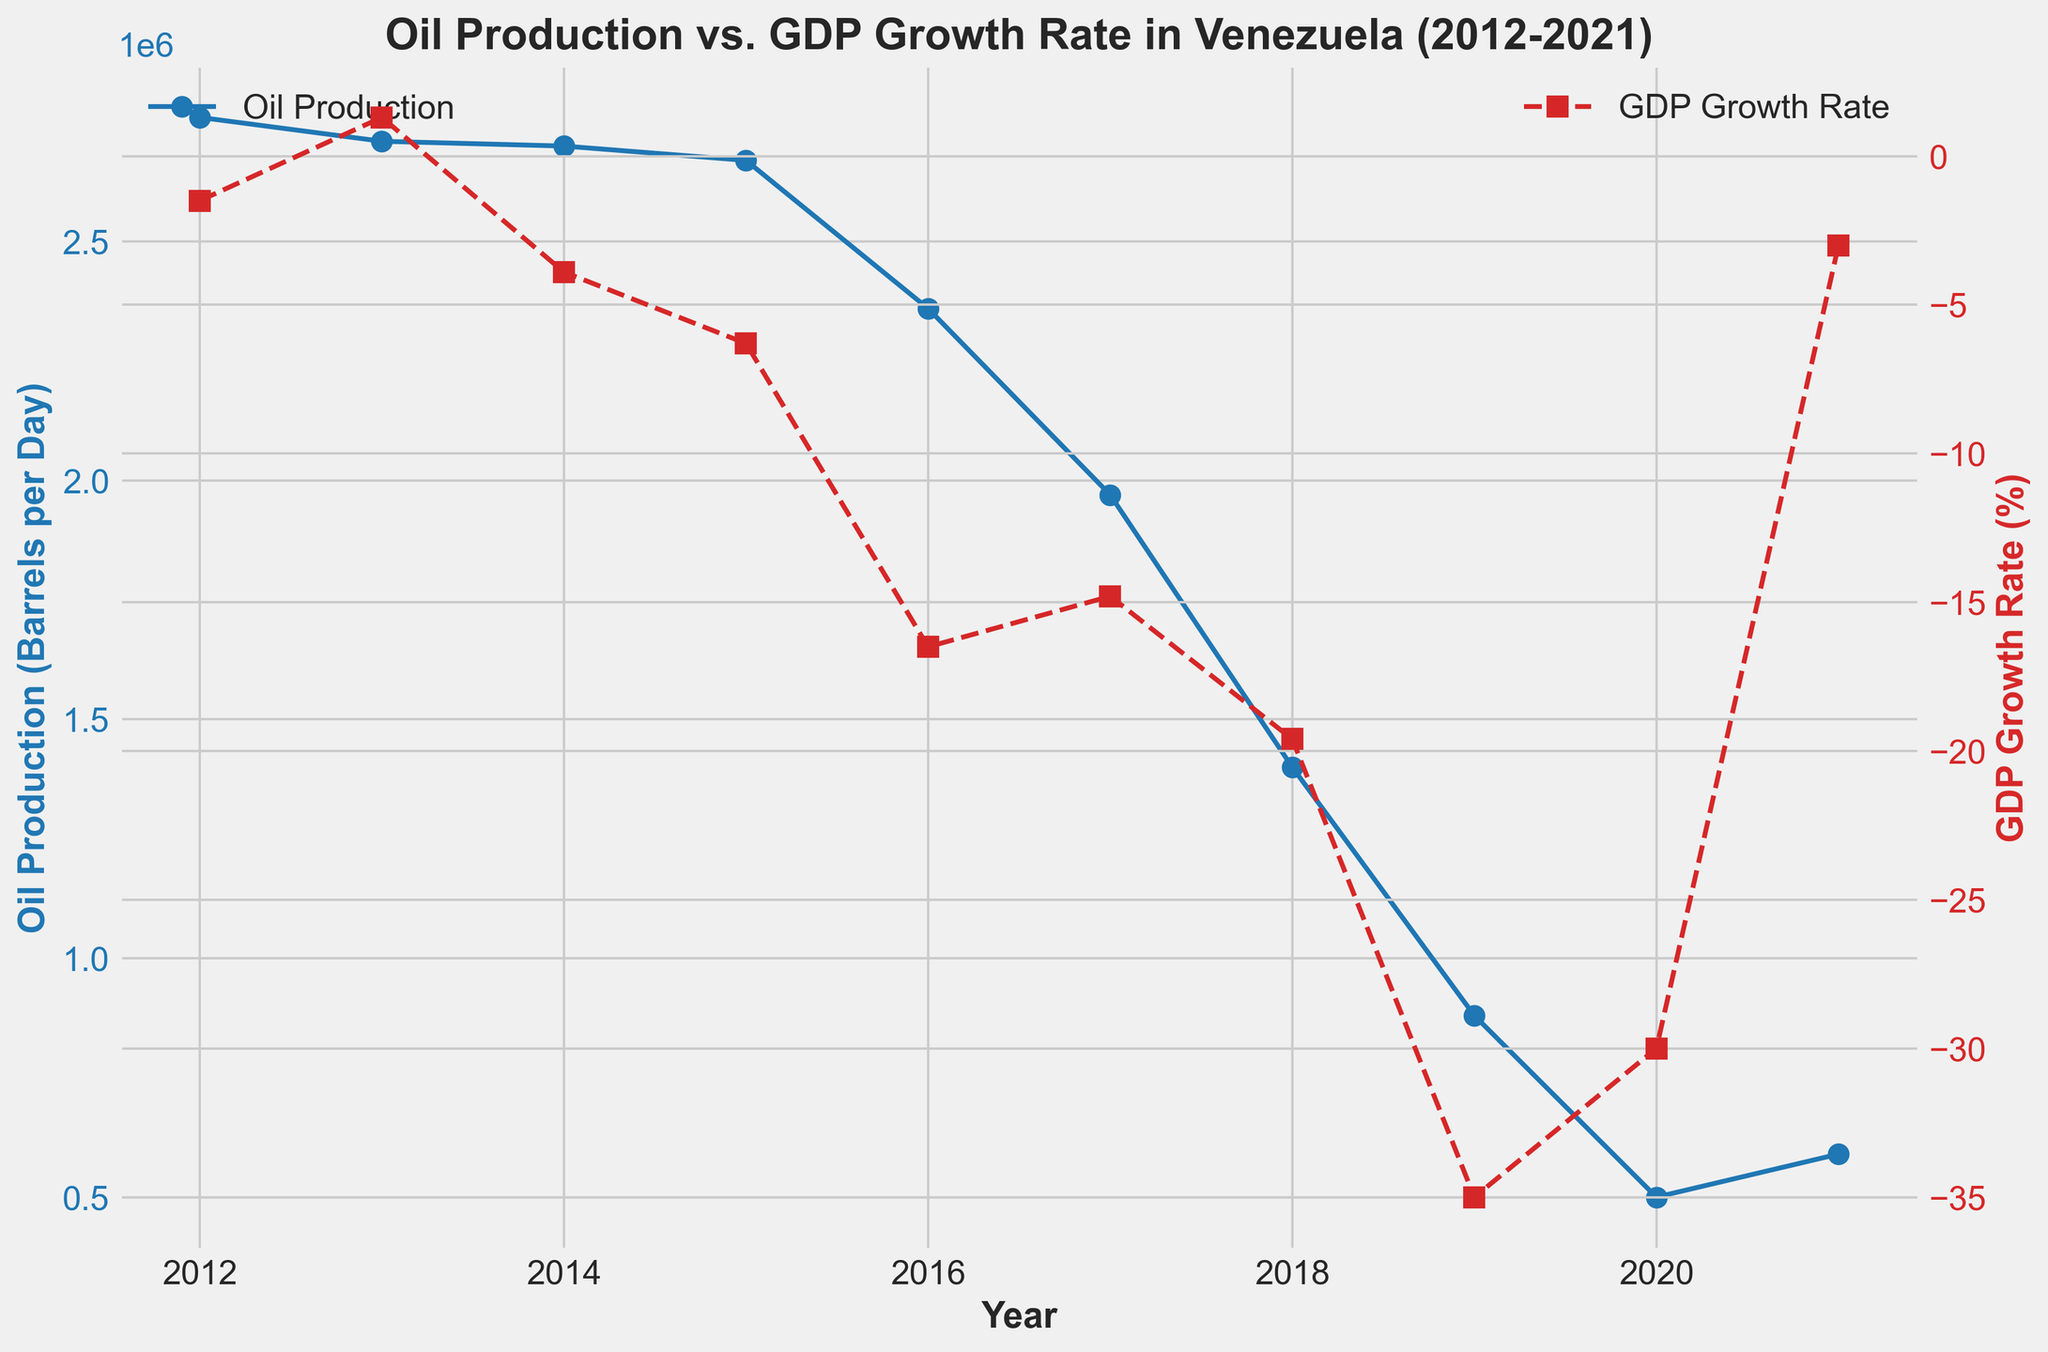What year had the highest oil production, and what was the GDP growth rate that year? The figure shows oil production in barrels per day on one axis and GDP growth rate on another. The highest oil production occurred in 2012, with over 2,760,000 barrels per day. The GDP growth rate that year was -1.5%.
Answer: 2012, -1.5% What was the difference in oil production between the year 2016 and the year 2020? From the figure, we can see that oil production in 2016 was 2,360,000 barrels per day and in 2020 it was 500,000 barrels per day. The difference is 2,360,000 - 500,000 = 1,860,000 barrels per day.
Answer: 1,860,000 barrels per day How did the GDP growth rate change from 2015 to 2018? The GDP growth rate in 2015 was -6.3%, and in 2018 it was -19.6%. The change is calculated as -19.6% - (-6.3%) = -13.3%.
Answer: -13.3% Which year experienced the steepest decline in oil production, and what was the amount of the decline? From the figure, the steepest decline in oil production occurred between 2018 and 2019. The production dropped from 1,400,000 barrels per day to 880,000 barrels per day, a decline of 1,400,000 - 880,000 = 520,000 barrels per day.
Answer: 2018-2019, 520,000 barrels per day Are there any years where the GDP growth rate increased compared to the previous year, and if so, which ones? In the figure, the GDP growth rate increased from 2012 (-1.5%) to 2013 (1.3%). This is the only instance of an increase in GDP growth rate when compared to the previous year.
Answer: 2012-2013 Which visual attributes help differentiate between the trends of oil production and GDP growth rate? The figure uses different colors and marker styles to differentiate between the two trends. Oil production is represented with blue solid lines and circle markers, while GDP growth rate is shown with red dashed lines and square markers.
Answer: Color and marker styles Which year experienced the steepest decline in GDP growth rate? The steepest decline in GDP growth rate occurred from 2019 (-35.0%) to 2020 (-30.0%). The change was 35.0 - 30.0 = 5.0 percentage points (even though it's not as large a percentage change as other individual years' drops).
Answer: 2019-2020, 5.0 percentage points What was the general trend of oil production and GDP growth rate from 2012 to 2021? The general trend shows that oil production consistently declined from 2012 (2,760,000 barrels per day) to 2021 (590,000 barrels per day). Correspondingly, the GDP growth rate also mostly declined, showing deeper negative values with some fluctuations, until a slight recovery in 2021 at -3.0%.
Answer: Declining for both 